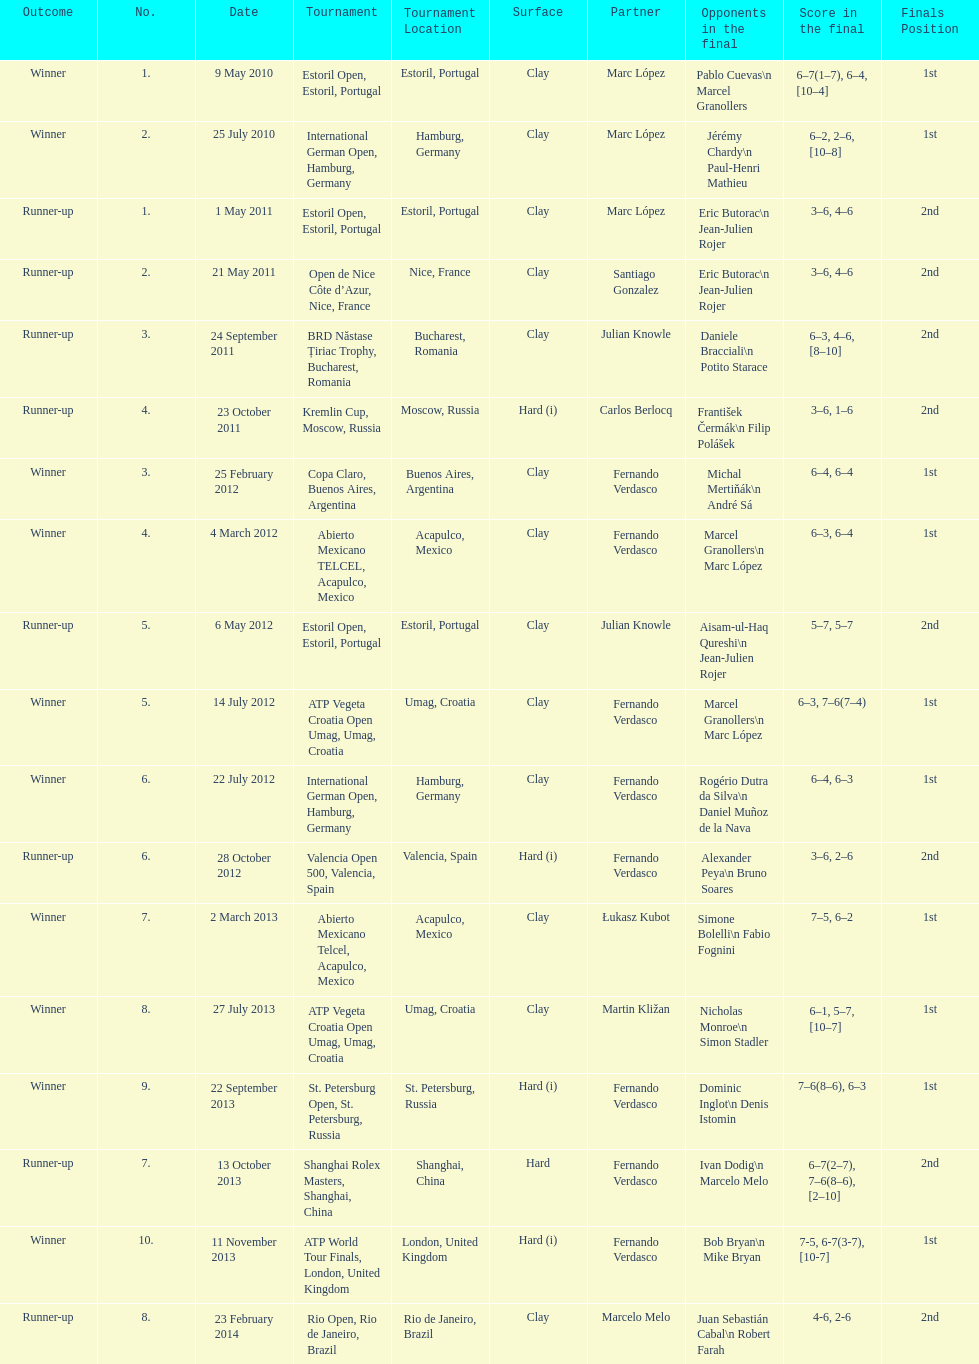How many partners from spain are listed? 2. 